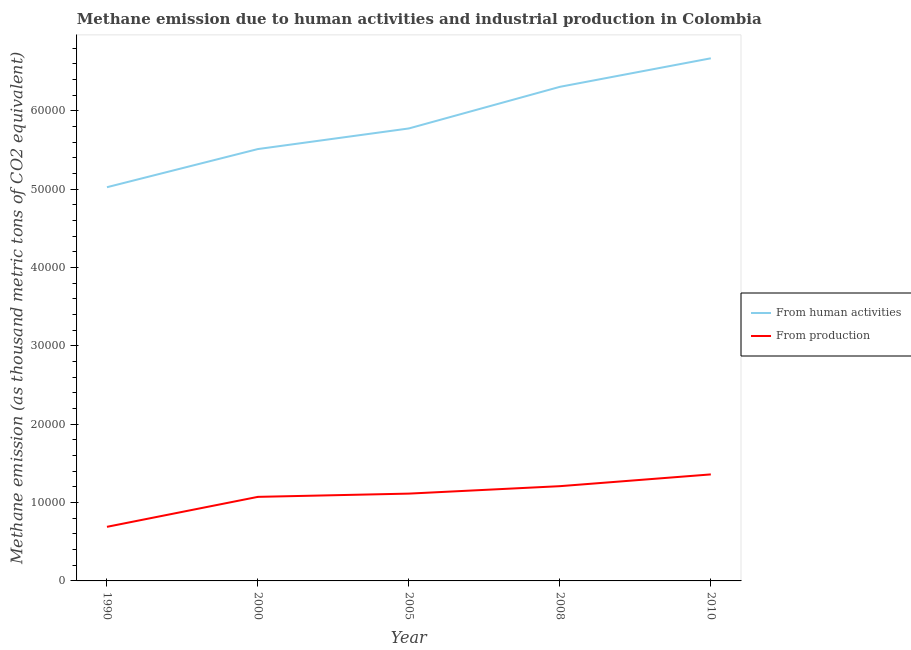Does the line corresponding to amount of emissions generated from industries intersect with the line corresponding to amount of emissions from human activities?
Offer a terse response. No. What is the amount of emissions generated from industries in 2005?
Your answer should be very brief. 1.11e+04. Across all years, what is the maximum amount of emissions generated from industries?
Your answer should be very brief. 1.36e+04. Across all years, what is the minimum amount of emissions from human activities?
Offer a very short reply. 5.02e+04. What is the total amount of emissions from human activities in the graph?
Provide a short and direct response. 2.93e+05. What is the difference between the amount of emissions generated from industries in 1990 and that in 2008?
Keep it short and to the point. -5189.3. What is the difference between the amount of emissions from human activities in 2008 and the amount of emissions generated from industries in 2005?
Your answer should be compact. 5.19e+04. What is the average amount of emissions from human activities per year?
Provide a short and direct response. 5.86e+04. In the year 2008, what is the difference between the amount of emissions from human activities and amount of emissions generated from industries?
Provide a short and direct response. 5.10e+04. In how many years, is the amount of emissions generated from industries greater than 14000 thousand metric tons?
Offer a terse response. 0. What is the ratio of the amount of emissions generated from industries in 1990 to that in 2005?
Your answer should be very brief. 0.62. What is the difference between the highest and the second highest amount of emissions generated from industries?
Provide a succinct answer. 1501.6. What is the difference between the highest and the lowest amount of emissions from human activities?
Offer a very short reply. 1.65e+04. Is the amount of emissions from human activities strictly greater than the amount of emissions generated from industries over the years?
Keep it short and to the point. Yes. Is the amount of emissions generated from industries strictly less than the amount of emissions from human activities over the years?
Your response must be concise. Yes. Are the values on the major ticks of Y-axis written in scientific E-notation?
Give a very brief answer. No. Does the graph contain any zero values?
Your answer should be very brief. No. Where does the legend appear in the graph?
Your answer should be very brief. Center right. How are the legend labels stacked?
Your answer should be very brief. Vertical. What is the title of the graph?
Provide a succinct answer. Methane emission due to human activities and industrial production in Colombia. Does "Manufacturing industries and construction" appear as one of the legend labels in the graph?
Offer a very short reply. No. What is the label or title of the X-axis?
Offer a terse response. Year. What is the label or title of the Y-axis?
Keep it short and to the point. Methane emission (as thousand metric tons of CO2 equivalent). What is the Methane emission (as thousand metric tons of CO2 equivalent) in From human activities in 1990?
Make the answer very short. 5.02e+04. What is the Methane emission (as thousand metric tons of CO2 equivalent) in From production in 1990?
Offer a terse response. 6902.6. What is the Methane emission (as thousand metric tons of CO2 equivalent) in From human activities in 2000?
Your response must be concise. 5.51e+04. What is the Methane emission (as thousand metric tons of CO2 equivalent) in From production in 2000?
Your answer should be compact. 1.07e+04. What is the Methane emission (as thousand metric tons of CO2 equivalent) of From human activities in 2005?
Offer a very short reply. 5.77e+04. What is the Methane emission (as thousand metric tons of CO2 equivalent) in From production in 2005?
Your response must be concise. 1.11e+04. What is the Methane emission (as thousand metric tons of CO2 equivalent) of From human activities in 2008?
Your answer should be compact. 6.31e+04. What is the Methane emission (as thousand metric tons of CO2 equivalent) in From production in 2008?
Your answer should be very brief. 1.21e+04. What is the Methane emission (as thousand metric tons of CO2 equivalent) of From human activities in 2010?
Ensure brevity in your answer.  6.67e+04. What is the Methane emission (as thousand metric tons of CO2 equivalent) of From production in 2010?
Ensure brevity in your answer.  1.36e+04. Across all years, what is the maximum Methane emission (as thousand metric tons of CO2 equivalent) of From human activities?
Give a very brief answer. 6.67e+04. Across all years, what is the maximum Methane emission (as thousand metric tons of CO2 equivalent) in From production?
Provide a short and direct response. 1.36e+04. Across all years, what is the minimum Methane emission (as thousand metric tons of CO2 equivalent) of From human activities?
Your answer should be very brief. 5.02e+04. Across all years, what is the minimum Methane emission (as thousand metric tons of CO2 equivalent) in From production?
Provide a succinct answer. 6902.6. What is the total Methane emission (as thousand metric tons of CO2 equivalent) in From human activities in the graph?
Ensure brevity in your answer.  2.93e+05. What is the total Methane emission (as thousand metric tons of CO2 equivalent) in From production in the graph?
Your answer should be very brief. 5.45e+04. What is the difference between the Methane emission (as thousand metric tons of CO2 equivalent) in From human activities in 1990 and that in 2000?
Provide a short and direct response. -4870.6. What is the difference between the Methane emission (as thousand metric tons of CO2 equivalent) of From production in 1990 and that in 2000?
Give a very brief answer. -3825.6. What is the difference between the Methane emission (as thousand metric tons of CO2 equivalent) in From human activities in 1990 and that in 2005?
Your response must be concise. -7500.3. What is the difference between the Methane emission (as thousand metric tons of CO2 equivalent) in From production in 1990 and that in 2005?
Make the answer very short. -4239.3. What is the difference between the Methane emission (as thousand metric tons of CO2 equivalent) of From human activities in 1990 and that in 2008?
Offer a very short reply. -1.28e+04. What is the difference between the Methane emission (as thousand metric tons of CO2 equivalent) of From production in 1990 and that in 2008?
Your answer should be very brief. -5189.3. What is the difference between the Methane emission (as thousand metric tons of CO2 equivalent) in From human activities in 1990 and that in 2010?
Provide a short and direct response. -1.65e+04. What is the difference between the Methane emission (as thousand metric tons of CO2 equivalent) of From production in 1990 and that in 2010?
Make the answer very short. -6690.9. What is the difference between the Methane emission (as thousand metric tons of CO2 equivalent) in From human activities in 2000 and that in 2005?
Ensure brevity in your answer.  -2629.7. What is the difference between the Methane emission (as thousand metric tons of CO2 equivalent) of From production in 2000 and that in 2005?
Provide a succinct answer. -413.7. What is the difference between the Methane emission (as thousand metric tons of CO2 equivalent) in From human activities in 2000 and that in 2008?
Make the answer very short. -7940.3. What is the difference between the Methane emission (as thousand metric tons of CO2 equivalent) in From production in 2000 and that in 2008?
Ensure brevity in your answer.  -1363.7. What is the difference between the Methane emission (as thousand metric tons of CO2 equivalent) of From human activities in 2000 and that in 2010?
Offer a terse response. -1.16e+04. What is the difference between the Methane emission (as thousand metric tons of CO2 equivalent) of From production in 2000 and that in 2010?
Your answer should be very brief. -2865.3. What is the difference between the Methane emission (as thousand metric tons of CO2 equivalent) of From human activities in 2005 and that in 2008?
Keep it short and to the point. -5310.6. What is the difference between the Methane emission (as thousand metric tons of CO2 equivalent) of From production in 2005 and that in 2008?
Offer a terse response. -950. What is the difference between the Methane emission (as thousand metric tons of CO2 equivalent) in From human activities in 2005 and that in 2010?
Give a very brief answer. -8951.6. What is the difference between the Methane emission (as thousand metric tons of CO2 equivalent) in From production in 2005 and that in 2010?
Offer a very short reply. -2451.6. What is the difference between the Methane emission (as thousand metric tons of CO2 equivalent) in From human activities in 2008 and that in 2010?
Give a very brief answer. -3641. What is the difference between the Methane emission (as thousand metric tons of CO2 equivalent) in From production in 2008 and that in 2010?
Your response must be concise. -1501.6. What is the difference between the Methane emission (as thousand metric tons of CO2 equivalent) in From human activities in 1990 and the Methane emission (as thousand metric tons of CO2 equivalent) in From production in 2000?
Offer a very short reply. 3.95e+04. What is the difference between the Methane emission (as thousand metric tons of CO2 equivalent) of From human activities in 1990 and the Methane emission (as thousand metric tons of CO2 equivalent) of From production in 2005?
Your answer should be compact. 3.91e+04. What is the difference between the Methane emission (as thousand metric tons of CO2 equivalent) in From human activities in 1990 and the Methane emission (as thousand metric tons of CO2 equivalent) in From production in 2008?
Your answer should be compact. 3.82e+04. What is the difference between the Methane emission (as thousand metric tons of CO2 equivalent) of From human activities in 1990 and the Methane emission (as thousand metric tons of CO2 equivalent) of From production in 2010?
Your answer should be compact. 3.66e+04. What is the difference between the Methane emission (as thousand metric tons of CO2 equivalent) of From human activities in 2000 and the Methane emission (as thousand metric tons of CO2 equivalent) of From production in 2005?
Keep it short and to the point. 4.40e+04. What is the difference between the Methane emission (as thousand metric tons of CO2 equivalent) of From human activities in 2000 and the Methane emission (as thousand metric tons of CO2 equivalent) of From production in 2008?
Your answer should be very brief. 4.30e+04. What is the difference between the Methane emission (as thousand metric tons of CO2 equivalent) of From human activities in 2000 and the Methane emission (as thousand metric tons of CO2 equivalent) of From production in 2010?
Ensure brevity in your answer.  4.15e+04. What is the difference between the Methane emission (as thousand metric tons of CO2 equivalent) in From human activities in 2005 and the Methane emission (as thousand metric tons of CO2 equivalent) in From production in 2008?
Your response must be concise. 4.57e+04. What is the difference between the Methane emission (as thousand metric tons of CO2 equivalent) in From human activities in 2005 and the Methane emission (as thousand metric tons of CO2 equivalent) in From production in 2010?
Provide a short and direct response. 4.41e+04. What is the difference between the Methane emission (as thousand metric tons of CO2 equivalent) in From human activities in 2008 and the Methane emission (as thousand metric tons of CO2 equivalent) in From production in 2010?
Provide a succinct answer. 4.95e+04. What is the average Methane emission (as thousand metric tons of CO2 equivalent) of From human activities per year?
Provide a succinct answer. 5.86e+04. What is the average Methane emission (as thousand metric tons of CO2 equivalent) of From production per year?
Make the answer very short. 1.09e+04. In the year 1990, what is the difference between the Methane emission (as thousand metric tons of CO2 equivalent) in From human activities and Methane emission (as thousand metric tons of CO2 equivalent) in From production?
Provide a succinct answer. 4.33e+04. In the year 2000, what is the difference between the Methane emission (as thousand metric tons of CO2 equivalent) in From human activities and Methane emission (as thousand metric tons of CO2 equivalent) in From production?
Your answer should be compact. 4.44e+04. In the year 2005, what is the difference between the Methane emission (as thousand metric tons of CO2 equivalent) in From human activities and Methane emission (as thousand metric tons of CO2 equivalent) in From production?
Your answer should be very brief. 4.66e+04. In the year 2008, what is the difference between the Methane emission (as thousand metric tons of CO2 equivalent) in From human activities and Methane emission (as thousand metric tons of CO2 equivalent) in From production?
Offer a terse response. 5.10e+04. In the year 2010, what is the difference between the Methane emission (as thousand metric tons of CO2 equivalent) of From human activities and Methane emission (as thousand metric tons of CO2 equivalent) of From production?
Your answer should be compact. 5.31e+04. What is the ratio of the Methane emission (as thousand metric tons of CO2 equivalent) of From human activities in 1990 to that in 2000?
Give a very brief answer. 0.91. What is the ratio of the Methane emission (as thousand metric tons of CO2 equivalent) in From production in 1990 to that in 2000?
Offer a very short reply. 0.64. What is the ratio of the Methane emission (as thousand metric tons of CO2 equivalent) of From human activities in 1990 to that in 2005?
Provide a short and direct response. 0.87. What is the ratio of the Methane emission (as thousand metric tons of CO2 equivalent) in From production in 1990 to that in 2005?
Ensure brevity in your answer.  0.62. What is the ratio of the Methane emission (as thousand metric tons of CO2 equivalent) in From human activities in 1990 to that in 2008?
Make the answer very short. 0.8. What is the ratio of the Methane emission (as thousand metric tons of CO2 equivalent) of From production in 1990 to that in 2008?
Offer a terse response. 0.57. What is the ratio of the Methane emission (as thousand metric tons of CO2 equivalent) in From human activities in 1990 to that in 2010?
Your answer should be compact. 0.75. What is the ratio of the Methane emission (as thousand metric tons of CO2 equivalent) in From production in 1990 to that in 2010?
Provide a succinct answer. 0.51. What is the ratio of the Methane emission (as thousand metric tons of CO2 equivalent) in From human activities in 2000 to that in 2005?
Keep it short and to the point. 0.95. What is the ratio of the Methane emission (as thousand metric tons of CO2 equivalent) of From production in 2000 to that in 2005?
Your response must be concise. 0.96. What is the ratio of the Methane emission (as thousand metric tons of CO2 equivalent) in From human activities in 2000 to that in 2008?
Offer a very short reply. 0.87. What is the ratio of the Methane emission (as thousand metric tons of CO2 equivalent) in From production in 2000 to that in 2008?
Offer a terse response. 0.89. What is the ratio of the Methane emission (as thousand metric tons of CO2 equivalent) of From human activities in 2000 to that in 2010?
Provide a succinct answer. 0.83. What is the ratio of the Methane emission (as thousand metric tons of CO2 equivalent) in From production in 2000 to that in 2010?
Keep it short and to the point. 0.79. What is the ratio of the Methane emission (as thousand metric tons of CO2 equivalent) in From human activities in 2005 to that in 2008?
Provide a short and direct response. 0.92. What is the ratio of the Methane emission (as thousand metric tons of CO2 equivalent) of From production in 2005 to that in 2008?
Offer a terse response. 0.92. What is the ratio of the Methane emission (as thousand metric tons of CO2 equivalent) of From human activities in 2005 to that in 2010?
Provide a succinct answer. 0.87. What is the ratio of the Methane emission (as thousand metric tons of CO2 equivalent) of From production in 2005 to that in 2010?
Provide a succinct answer. 0.82. What is the ratio of the Methane emission (as thousand metric tons of CO2 equivalent) in From human activities in 2008 to that in 2010?
Ensure brevity in your answer.  0.95. What is the ratio of the Methane emission (as thousand metric tons of CO2 equivalent) of From production in 2008 to that in 2010?
Provide a short and direct response. 0.89. What is the difference between the highest and the second highest Methane emission (as thousand metric tons of CO2 equivalent) of From human activities?
Your answer should be compact. 3641. What is the difference between the highest and the second highest Methane emission (as thousand metric tons of CO2 equivalent) in From production?
Your response must be concise. 1501.6. What is the difference between the highest and the lowest Methane emission (as thousand metric tons of CO2 equivalent) in From human activities?
Make the answer very short. 1.65e+04. What is the difference between the highest and the lowest Methane emission (as thousand metric tons of CO2 equivalent) of From production?
Keep it short and to the point. 6690.9. 